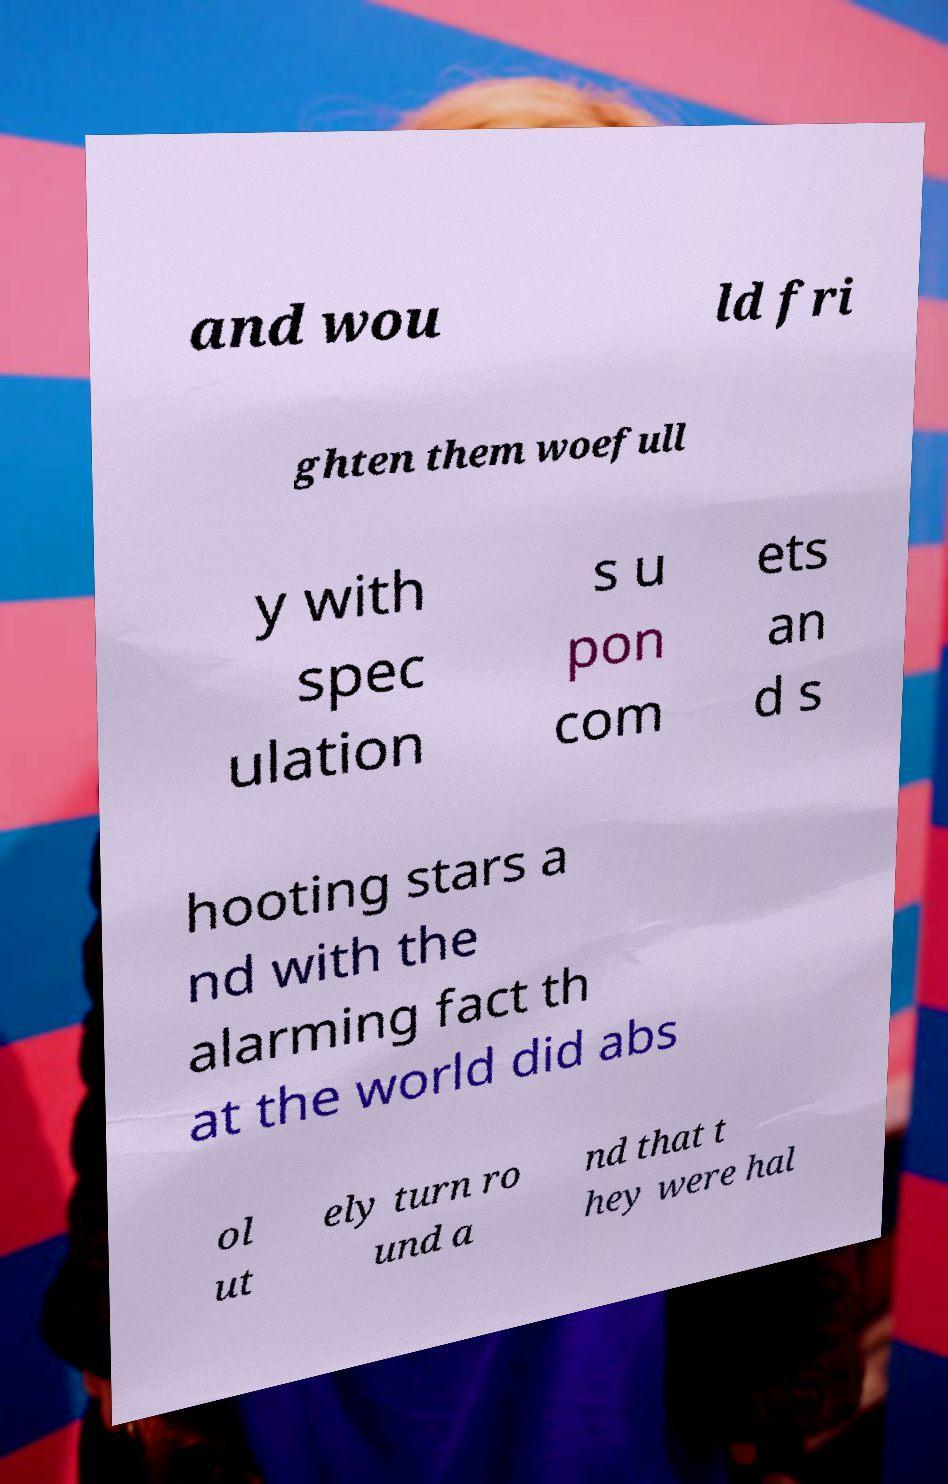I need the written content from this picture converted into text. Can you do that? and wou ld fri ghten them woefull y with spec ulation s u pon com ets an d s hooting stars a nd with the alarming fact th at the world did abs ol ut ely turn ro und a nd that t hey were hal 